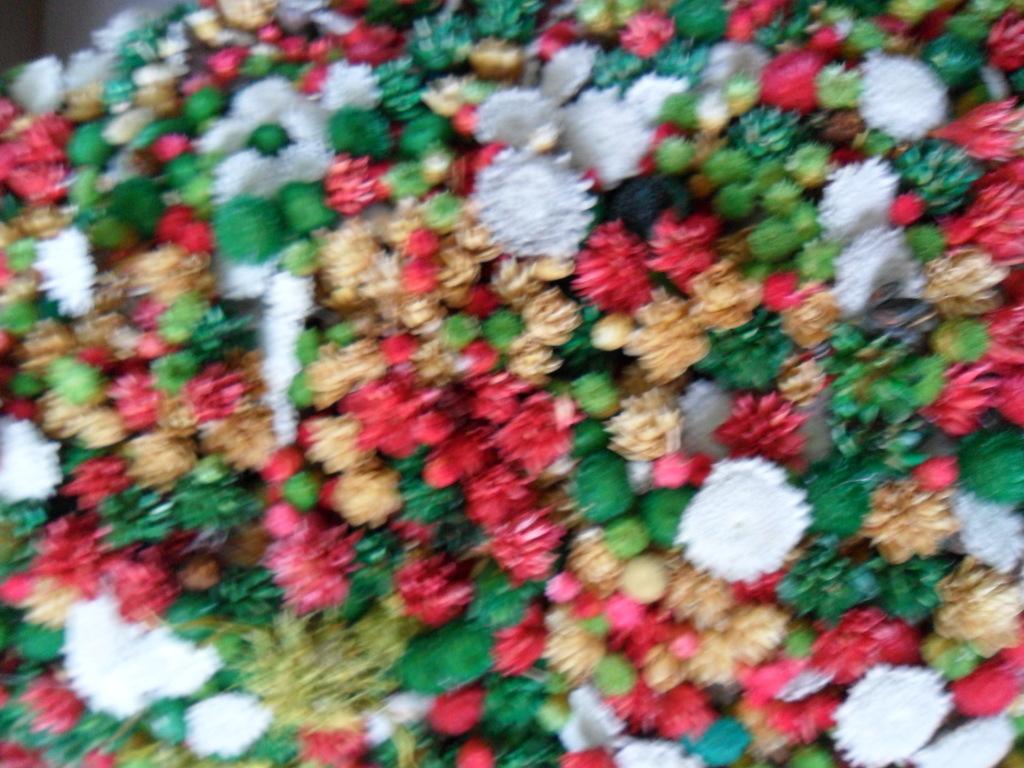How would you summarize this image in a sentence or two? In this image we can see flowers of different colors, and the picture is blurred. 